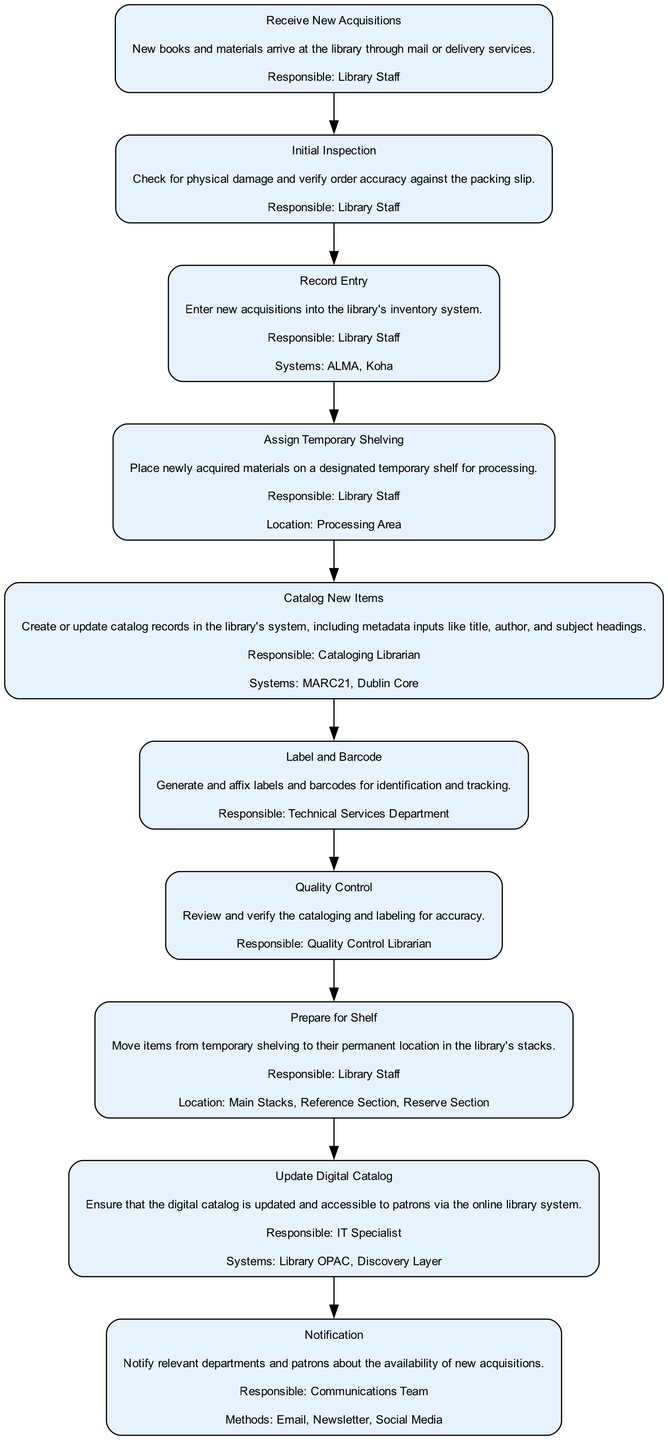What is the first step in the workflow? The first step listed in the workflow is "Receive New Acquisitions". This is the starting point from which all other steps follow.
Answer: Receive New Acquisitions Who is responsible for the "Quality Control" step? The "Quality Control" step is designated to the "Quality Control Librarian", as specified in the description.
Answer: Quality Control Librarian How many systems are mentioned for cataloging new items? The systems mentioned for cataloging new items are "MARC21" and "Dublin Core", which totals two systems.
Answer: 2 What action occurs after "Label and Barcode"? The action that follows "Label and Barcode" is "Quality Control", indicating the sequence of the workflow process.
Answer: Quality Control What location is specified for "Assign Temporary Shelving"? The "Assign Temporary Shelving" step specifies the "Processing Area" as the location where this action takes place.
Answer: Processing Area Which responsible party is involved in updating the digital catalog? The responsible party for updating the digital catalog is the "IT Specialist", as indicated in the workflow description.
Answer: IT Specialist Which step includes methods for notification? The step that includes methods for notification is "Notification", where it specifies "Email, Newsletter, Social Media" as the methods used for communication.
Answer: Notification How many steps are there in total within the workflow? There are a total of ten steps outlined in the workflow for handling and cataloguing new library acquisitions.
Answer: 10 What is the purpose of the "Prepare for Shelf" step? The purpose of the "Prepare for Shelf" step is to move items from temporary shelving to their permanent location in the library's stacks.
Answer: Move items to permanent location 